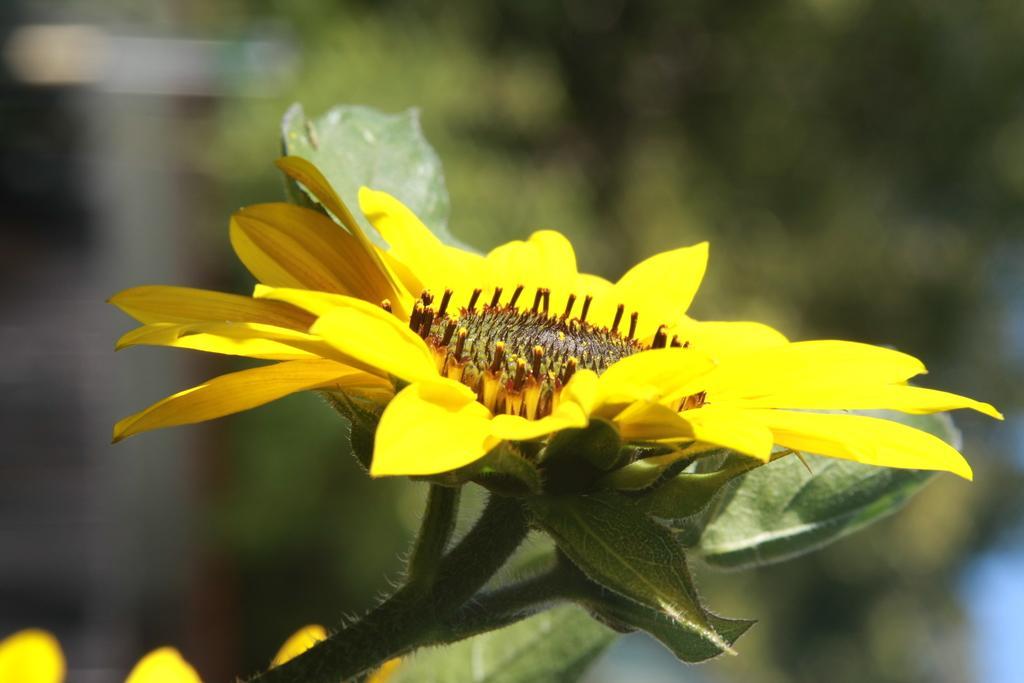How would you summarize this image in a sentence or two? In this image, we can see a plant with flowers and the background is blurry. 